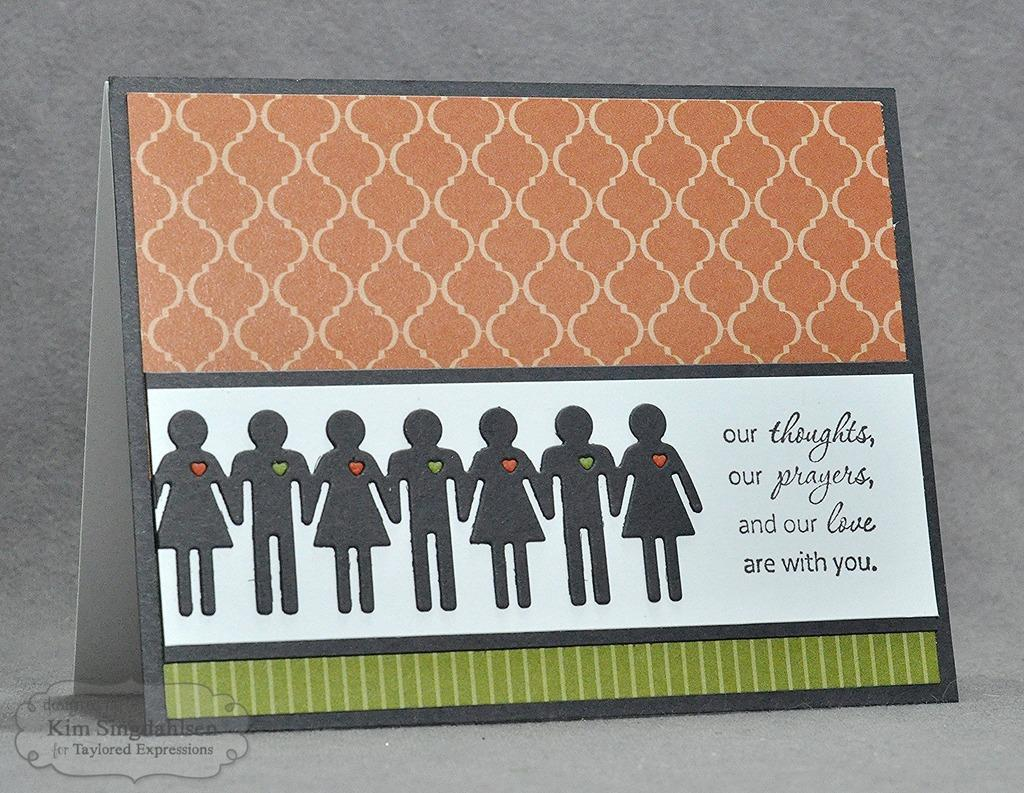What type of image is present in the picture? There is a greeting in the image. What elements are included in the greeting? The greeting contains cartoon images and text. Is there any additional information or branding on the image? Yes, there is a watermark on the bottom left of the image. What is the minister doing in the image? There is no minister present in the image; it contains a greeting with cartoon images and text. 